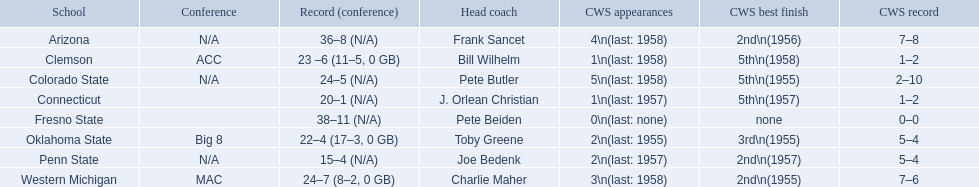What is the complete list of schools? Arizona, Clemson, Colorado State, Connecticut, Fresno State, Oklahoma State, Penn State, Western Michigan. Which team secured less than 20 victories? Penn State. 